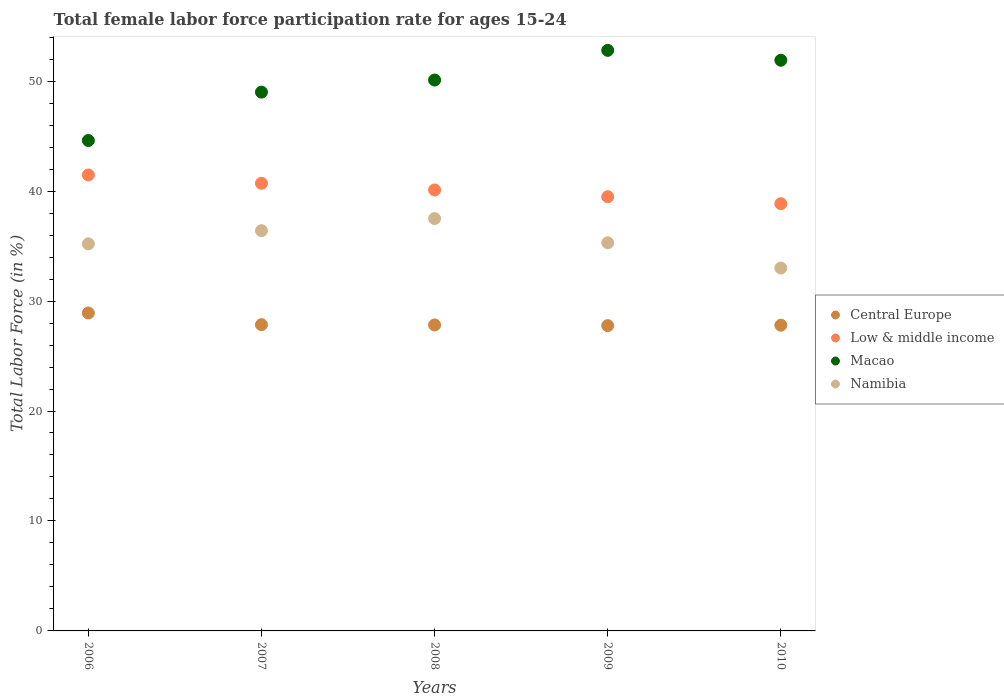How many different coloured dotlines are there?
Make the answer very short. 4. What is the female labor force participation rate in Macao in 2010?
Ensure brevity in your answer.  51.9. Across all years, what is the maximum female labor force participation rate in Central Europe?
Give a very brief answer. 28.91. Across all years, what is the minimum female labor force participation rate in Low & middle income?
Make the answer very short. 38.86. In which year was the female labor force participation rate in Namibia minimum?
Your answer should be very brief. 2010. What is the total female labor force participation rate in Central Europe in the graph?
Offer a very short reply. 140.16. What is the difference between the female labor force participation rate in Macao in 2007 and that in 2009?
Provide a short and direct response. -3.8. What is the difference between the female labor force participation rate in Central Europe in 2010 and the female labor force participation rate in Low & middle income in 2008?
Offer a terse response. -12.3. What is the average female labor force participation rate in Macao per year?
Offer a terse response. 49.68. In the year 2009, what is the difference between the female labor force participation rate in Low & middle income and female labor force participation rate in Namibia?
Provide a short and direct response. 4.19. In how many years, is the female labor force participation rate in Namibia greater than 52 %?
Offer a very short reply. 0. What is the ratio of the female labor force participation rate in Low & middle income in 2006 to that in 2010?
Provide a short and direct response. 1.07. Is the difference between the female labor force participation rate in Low & middle income in 2007 and 2009 greater than the difference between the female labor force participation rate in Namibia in 2007 and 2009?
Ensure brevity in your answer.  Yes. What is the difference between the highest and the second highest female labor force participation rate in Low & middle income?
Make the answer very short. 0.75. What is the difference between the highest and the lowest female labor force participation rate in Macao?
Provide a short and direct response. 8.2. In how many years, is the female labor force participation rate in Low & middle income greater than the average female labor force participation rate in Low & middle income taken over all years?
Keep it short and to the point. 2. Is the sum of the female labor force participation rate in Central Europe in 2007 and 2010 greater than the maximum female labor force participation rate in Namibia across all years?
Your response must be concise. Yes. Is the female labor force participation rate in Namibia strictly less than the female labor force participation rate in Low & middle income over the years?
Your answer should be very brief. Yes. What is the difference between two consecutive major ticks on the Y-axis?
Provide a short and direct response. 10. Are the values on the major ticks of Y-axis written in scientific E-notation?
Provide a succinct answer. No. Does the graph contain any zero values?
Offer a very short reply. No. How are the legend labels stacked?
Offer a very short reply. Vertical. What is the title of the graph?
Provide a short and direct response. Total female labor force participation rate for ages 15-24. Does "Kosovo" appear as one of the legend labels in the graph?
Offer a very short reply. No. What is the label or title of the X-axis?
Give a very brief answer. Years. What is the label or title of the Y-axis?
Make the answer very short. Total Labor Force (in %). What is the Total Labor Force (in %) of Central Europe in 2006?
Ensure brevity in your answer.  28.91. What is the Total Labor Force (in %) of Low & middle income in 2006?
Give a very brief answer. 41.47. What is the Total Labor Force (in %) in Macao in 2006?
Keep it short and to the point. 44.6. What is the Total Labor Force (in %) of Namibia in 2006?
Your answer should be very brief. 35.2. What is the Total Labor Force (in %) in Central Europe in 2007?
Provide a short and direct response. 27.85. What is the Total Labor Force (in %) in Low & middle income in 2007?
Ensure brevity in your answer.  40.71. What is the Total Labor Force (in %) of Macao in 2007?
Your answer should be very brief. 49. What is the Total Labor Force (in %) in Namibia in 2007?
Give a very brief answer. 36.4. What is the Total Labor Force (in %) of Central Europe in 2008?
Offer a terse response. 27.82. What is the Total Labor Force (in %) in Low & middle income in 2008?
Your answer should be very brief. 40.1. What is the Total Labor Force (in %) in Macao in 2008?
Make the answer very short. 50.1. What is the Total Labor Force (in %) of Namibia in 2008?
Provide a short and direct response. 37.5. What is the Total Labor Force (in %) in Central Europe in 2009?
Offer a terse response. 27.77. What is the Total Labor Force (in %) in Low & middle income in 2009?
Make the answer very short. 39.49. What is the Total Labor Force (in %) of Macao in 2009?
Ensure brevity in your answer.  52.8. What is the Total Labor Force (in %) of Namibia in 2009?
Provide a short and direct response. 35.3. What is the Total Labor Force (in %) of Central Europe in 2010?
Your response must be concise. 27.8. What is the Total Labor Force (in %) of Low & middle income in 2010?
Ensure brevity in your answer.  38.86. What is the Total Labor Force (in %) in Macao in 2010?
Offer a terse response. 51.9. What is the Total Labor Force (in %) in Namibia in 2010?
Ensure brevity in your answer.  33. Across all years, what is the maximum Total Labor Force (in %) of Central Europe?
Ensure brevity in your answer.  28.91. Across all years, what is the maximum Total Labor Force (in %) of Low & middle income?
Keep it short and to the point. 41.47. Across all years, what is the maximum Total Labor Force (in %) of Macao?
Provide a short and direct response. 52.8. Across all years, what is the maximum Total Labor Force (in %) in Namibia?
Provide a short and direct response. 37.5. Across all years, what is the minimum Total Labor Force (in %) of Central Europe?
Keep it short and to the point. 27.77. Across all years, what is the minimum Total Labor Force (in %) of Low & middle income?
Your response must be concise. 38.86. Across all years, what is the minimum Total Labor Force (in %) in Macao?
Give a very brief answer. 44.6. Across all years, what is the minimum Total Labor Force (in %) of Namibia?
Offer a terse response. 33. What is the total Total Labor Force (in %) of Central Europe in the graph?
Give a very brief answer. 140.16. What is the total Total Labor Force (in %) of Low & middle income in the graph?
Your response must be concise. 200.62. What is the total Total Labor Force (in %) in Macao in the graph?
Provide a short and direct response. 248.4. What is the total Total Labor Force (in %) in Namibia in the graph?
Keep it short and to the point. 177.4. What is the difference between the Total Labor Force (in %) of Central Europe in 2006 and that in 2007?
Give a very brief answer. 1.06. What is the difference between the Total Labor Force (in %) in Low & middle income in 2006 and that in 2007?
Provide a succinct answer. 0.75. What is the difference between the Total Labor Force (in %) of Macao in 2006 and that in 2007?
Your answer should be compact. -4.4. What is the difference between the Total Labor Force (in %) of Central Europe in 2006 and that in 2008?
Provide a short and direct response. 1.09. What is the difference between the Total Labor Force (in %) of Low & middle income in 2006 and that in 2008?
Provide a short and direct response. 1.37. What is the difference between the Total Labor Force (in %) in Central Europe in 2006 and that in 2009?
Keep it short and to the point. 1.15. What is the difference between the Total Labor Force (in %) in Low & middle income in 2006 and that in 2009?
Your answer should be compact. 1.98. What is the difference between the Total Labor Force (in %) in Macao in 2006 and that in 2009?
Make the answer very short. -8.2. What is the difference between the Total Labor Force (in %) of Central Europe in 2006 and that in 2010?
Your answer should be compact. 1.11. What is the difference between the Total Labor Force (in %) in Low & middle income in 2006 and that in 2010?
Offer a very short reply. 2.61. What is the difference between the Total Labor Force (in %) of Central Europe in 2007 and that in 2008?
Make the answer very short. 0.03. What is the difference between the Total Labor Force (in %) of Low & middle income in 2007 and that in 2008?
Ensure brevity in your answer.  0.61. What is the difference between the Total Labor Force (in %) in Central Europe in 2007 and that in 2009?
Offer a terse response. 0.08. What is the difference between the Total Labor Force (in %) of Low & middle income in 2007 and that in 2009?
Ensure brevity in your answer.  1.23. What is the difference between the Total Labor Force (in %) in Namibia in 2007 and that in 2009?
Make the answer very short. 1.1. What is the difference between the Total Labor Force (in %) in Central Europe in 2007 and that in 2010?
Ensure brevity in your answer.  0.05. What is the difference between the Total Labor Force (in %) in Low & middle income in 2007 and that in 2010?
Ensure brevity in your answer.  1.86. What is the difference between the Total Labor Force (in %) of Macao in 2007 and that in 2010?
Offer a terse response. -2.9. What is the difference between the Total Labor Force (in %) of Namibia in 2007 and that in 2010?
Your answer should be compact. 3.4. What is the difference between the Total Labor Force (in %) of Central Europe in 2008 and that in 2009?
Provide a short and direct response. 0.06. What is the difference between the Total Labor Force (in %) in Low & middle income in 2008 and that in 2009?
Provide a succinct answer. 0.61. What is the difference between the Total Labor Force (in %) in Macao in 2008 and that in 2009?
Ensure brevity in your answer.  -2.7. What is the difference between the Total Labor Force (in %) of Namibia in 2008 and that in 2009?
Offer a very short reply. 2.2. What is the difference between the Total Labor Force (in %) in Central Europe in 2008 and that in 2010?
Keep it short and to the point. 0.02. What is the difference between the Total Labor Force (in %) in Low & middle income in 2008 and that in 2010?
Offer a very short reply. 1.24. What is the difference between the Total Labor Force (in %) in Macao in 2008 and that in 2010?
Your answer should be compact. -1.8. What is the difference between the Total Labor Force (in %) in Central Europe in 2009 and that in 2010?
Make the answer very short. -0.04. What is the difference between the Total Labor Force (in %) of Low & middle income in 2009 and that in 2010?
Make the answer very short. 0.63. What is the difference between the Total Labor Force (in %) in Central Europe in 2006 and the Total Labor Force (in %) in Low & middle income in 2007?
Provide a succinct answer. -11.8. What is the difference between the Total Labor Force (in %) of Central Europe in 2006 and the Total Labor Force (in %) of Macao in 2007?
Give a very brief answer. -20.09. What is the difference between the Total Labor Force (in %) of Central Europe in 2006 and the Total Labor Force (in %) of Namibia in 2007?
Give a very brief answer. -7.49. What is the difference between the Total Labor Force (in %) in Low & middle income in 2006 and the Total Labor Force (in %) in Macao in 2007?
Make the answer very short. -7.53. What is the difference between the Total Labor Force (in %) in Low & middle income in 2006 and the Total Labor Force (in %) in Namibia in 2007?
Your response must be concise. 5.07. What is the difference between the Total Labor Force (in %) of Central Europe in 2006 and the Total Labor Force (in %) of Low & middle income in 2008?
Offer a very short reply. -11.19. What is the difference between the Total Labor Force (in %) of Central Europe in 2006 and the Total Labor Force (in %) of Macao in 2008?
Your answer should be compact. -21.19. What is the difference between the Total Labor Force (in %) in Central Europe in 2006 and the Total Labor Force (in %) in Namibia in 2008?
Provide a succinct answer. -8.59. What is the difference between the Total Labor Force (in %) of Low & middle income in 2006 and the Total Labor Force (in %) of Macao in 2008?
Give a very brief answer. -8.63. What is the difference between the Total Labor Force (in %) of Low & middle income in 2006 and the Total Labor Force (in %) of Namibia in 2008?
Provide a succinct answer. 3.97. What is the difference between the Total Labor Force (in %) in Central Europe in 2006 and the Total Labor Force (in %) in Low & middle income in 2009?
Offer a very short reply. -10.58. What is the difference between the Total Labor Force (in %) of Central Europe in 2006 and the Total Labor Force (in %) of Macao in 2009?
Your answer should be very brief. -23.89. What is the difference between the Total Labor Force (in %) of Central Europe in 2006 and the Total Labor Force (in %) of Namibia in 2009?
Your answer should be very brief. -6.39. What is the difference between the Total Labor Force (in %) of Low & middle income in 2006 and the Total Labor Force (in %) of Macao in 2009?
Provide a short and direct response. -11.33. What is the difference between the Total Labor Force (in %) of Low & middle income in 2006 and the Total Labor Force (in %) of Namibia in 2009?
Give a very brief answer. 6.17. What is the difference between the Total Labor Force (in %) of Macao in 2006 and the Total Labor Force (in %) of Namibia in 2009?
Your answer should be very brief. 9.3. What is the difference between the Total Labor Force (in %) in Central Europe in 2006 and the Total Labor Force (in %) in Low & middle income in 2010?
Offer a terse response. -9.95. What is the difference between the Total Labor Force (in %) in Central Europe in 2006 and the Total Labor Force (in %) in Macao in 2010?
Offer a terse response. -22.99. What is the difference between the Total Labor Force (in %) in Central Europe in 2006 and the Total Labor Force (in %) in Namibia in 2010?
Ensure brevity in your answer.  -4.09. What is the difference between the Total Labor Force (in %) in Low & middle income in 2006 and the Total Labor Force (in %) in Macao in 2010?
Provide a short and direct response. -10.43. What is the difference between the Total Labor Force (in %) of Low & middle income in 2006 and the Total Labor Force (in %) of Namibia in 2010?
Offer a terse response. 8.47. What is the difference between the Total Labor Force (in %) of Macao in 2006 and the Total Labor Force (in %) of Namibia in 2010?
Provide a short and direct response. 11.6. What is the difference between the Total Labor Force (in %) in Central Europe in 2007 and the Total Labor Force (in %) in Low & middle income in 2008?
Your answer should be compact. -12.25. What is the difference between the Total Labor Force (in %) of Central Europe in 2007 and the Total Labor Force (in %) of Macao in 2008?
Ensure brevity in your answer.  -22.25. What is the difference between the Total Labor Force (in %) in Central Europe in 2007 and the Total Labor Force (in %) in Namibia in 2008?
Your response must be concise. -9.65. What is the difference between the Total Labor Force (in %) in Low & middle income in 2007 and the Total Labor Force (in %) in Macao in 2008?
Provide a short and direct response. -9.39. What is the difference between the Total Labor Force (in %) in Low & middle income in 2007 and the Total Labor Force (in %) in Namibia in 2008?
Offer a very short reply. 3.21. What is the difference between the Total Labor Force (in %) in Macao in 2007 and the Total Labor Force (in %) in Namibia in 2008?
Your answer should be compact. 11.5. What is the difference between the Total Labor Force (in %) of Central Europe in 2007 and the Total Labor Force (in %) of Low & middle income in 2009?
Your answer should be compact. -11.64. What is the difference between the Total Labor Force (in %) of Central Europe in 2007 and the Total Labor Force (in %) of Macao in 2009?
Provide a succinct answer. -24.95. What is the difference between the Total Labor Force (in %) of Central Europe in 2007 and the Total Labor Force (in %) of Namibia in 2009?
Your answer should be very brief. -7.45. What is the difference between the Total Labor Force (in %) of Low & middle income in 2007 and the Total Labor Force (in %) of Macao in 2009?
Your answer should be compact. -12.09. What is the difference between the Total Labor Force (in %) of Low & middle income in 2007 and the Total Labor Force (in %) of Namibia in 2009?
Ensure brevity in your answer.  5.41. What is the difference between the Total Labor Force (in %) in Central Europe in 2007 and the Total Labor Force (in %) in Low & middle income in 2010?
Offer a terse response. -11.01. What is the difference between the Total Labor Force (in %) of Central Europe in 2007 and the Total Labor Force (in %) of Macao in 2010?
Keep it short and to the point. -24.05. What is the difference between the Total Labor Force (in %) of Central Europe in 2007 and the Total Labor Force (in %) of Namibia in 2010?
Your answer should be very brief. -5.15. What is the difference between the Total Labor Force (in %) of Low & middle income in 2007 and the Total Labor Force (in %) of Macao in 2010?
Give a very brief answer. -11.19. What is the difference between the Total Labor Force (in %) of Low & middle income in 2007 and the Total Labor Force (in %) of Namibia in 2010?
Keep it short and to the point. 7.71. What is the difference between the Total Labor Force (in %) in Central Europe in 2008 and the Total Labor Force (in %) in Low & middle income in 2009?
Offer a terse response. -11.66. What is the difference between the Total Labor Force (in %) of Central Europe in 2008 and the Total Labor Force (in %) of Macao in 2009?
Make the answer very short. -24.98. What is the difference between the Total Labor Force (in %) in Central Europe in 2008 and the Total Labor Force (in %) in Namibia in 2009?
Provide a succinct answer. -7.48. What is the difference between the Total Labor Force (in %) of Low & middle income in 2008 and the Total Labor Force (in %) of Macao in 2009?
Keep it short and to the point. -12.7. What is the difference between the Total Labor Force (in %) in Low & middle income in 2008 and the Total Labor Force (in %) in Namibia in 2009?
Keep it short and to the point. 4.8. What is the difference between the Total Labor Force (in %) in Central Europe in 2008 and the Total Labor Force (in %) in Low & middle income in 2010?
Your answer should be compact. -11.03. What is the difference between the Total Labor Force (in %) of Central Europe in 2008 and the Total Labor Force (in %) of Macao in 2010?
Provide a succinct answer. -24.08. What is the difference between the Total Labor Force (in %) in Central Europe in 2008 and the Total Labor Force (in %) in Namibia in 2010?
Your answer should be compact. -5.18. What is the difference between the Total Labor Force (in %) in Low & middle income in 2008 and the Total Labor Force (in %) in Macao in 2010?
Keep it short and to the point. -11.8. What is the difference between the Total Labor Force (in %) in Low & middle income in 2008 and the Total Labor Force (in %) in Namibia in 2010?
Keep it short and to the point. 7.1. What is the difference between the Total Labor Force (in %) in Macao in 2008 and the Total Labor Force (in %) in Namibia in 2010?
Make the answer very short. 17.1. What is the difference between the Total Labor Force (in %) in Central Europe in 2009 and the Total Labor Force (in %) in Low & middle income in 2010?
Your answer should be compact. -11.09. What is the difference between the Total Labor Force (in %) in Central Europe in 2009 and the Total Labor Force (in %) in Macao in 2010?
Ensure brevity in your answer.  -24.13. What is the difference between the Total Labor Force (in %) in Central Europe in 2009 and the Total Labor Force (in %) in Namibia in 2010?
Your response must be concise. -5.23. What is the difference between the Total Labor Force (in %) of Low & middle income in 2009 and the Total Labor Force (in %) of Macao in 2010?
Provide a succinct answer. -12.41. What is the difference between the Total Labor Force (in %) of Low & middle income in 2009 and the Total Labor Force (in %) of Namibia in 2010?
Your response must be concise. 6.49. What is the difference between the Total Labor Force (in %) of Macao in 2009 and the Total Labor Force (in %) of Namibia in 2010?
Keep it short and to the point. 19.8. What is the average Total Labor Force (in %) of Central Europe per year?
Your answer should be compact. 28.03. What is the average Total Labor Force (in %) of Low & middle income per year?
Keep it short and to the point. 40.12. What is the average Total Labor Force (in %) of Macao per year?
Keep it short and to the point. 49.68. What is the average Total Labor Force (in %) in Namibia per year?
Offer a very short reply. 35.48. In the year 2006, what is the difference between the Total Labor Force (in %) in Central Europe and Total Labor Force (in %) in Low & middle income?
Give a very brief answer. -12.55. In the year 2006, what is the difference between the Total Labor Force (in %) in Central Europe and Total Labor Force (in %) in Macao?
Provide a short and direct response. -15.69. In the year 2006, what is the difference between the Total Labor Force (in %) of Central Europe and Total Labor Force (in %) of Namibia?
Provide a succinct answer. -6.29. In the year 2006, what is the difference between the Total Labor Force (in %) of Low & middle income and Total Labor Force (in %) of Macao?
Provide a short and direct response. -3.13. In the year 2006, what is the difference between the Total Labor Force (in %) in Low & middle income and Total Labor Force (in %) in Namibia?
Your answer should be very brief. 6.27. In the year 2006, what is the difference between the Total Labor Force (in %) in Macao and Total Labor Force (in %) in Namibia?
Provide a short and direct response. 9.4. In the year 2007, what is the difference between the Total Labor Force (in %) of Central Europe and Total Labor Force (in %) of Low & middle income?
Your answer should be very brief. -12.86. In the year 2007, what is the difference between the Total Labor Force (in %) of Central Europe and Total Labor Force (in %) of Macao?
Provide a short and direct response. -21.15. In the year 2007, what is the difference between the Total Labor Force (in %) of Central Europe and Total Labor Force (in %) of Namibia?
Provide a short and direct response. -8.55. In the year 2007, what is the difference between the Total Labor Force (in %) in Low & middle income and Total Labor Force (in %) in Macao?
Provide a short and direct response. -8.29. In the year 2007, what is the difference between the Total Labor Force (in %) of Low & middle income and Total Labor Force (in %) of Namibia?
Offer a very short reply. 4.31. In the year 2008, what is the difference between the Total Labor Force (in %) of Central Europe and Total Labor Force (in %) of Low & middle income?
Offer a very short reply. -12.28. In the year 2008, what is the difference between the Total Labor Force (in %) in Central Europe and Total Labor Force (in %) in Macao?
Your answer should be very brief. -22.28. In the year 2008, what is the difference between the Total Labor Force (in %) of Central Europe and Total Labor Force (in %) of Namibia?
Your answer should be very brief. -9.68. In the year 2008, what is the difference between the Total Labor Force (in %) in Low & middle income and Total Labor Force (in %) in Macao?
Provide a succinct answer. -10. In the year 2008, what is the difference between the Total Labor Force (in %) of Low & middle income and Total Labor Force (in %) of Namibia?
Offer a terse response. 2.6. In the year 2009, what is the difference between the Total Labor Force (in %) of Central Europe and Total Labor Force (in %) of Low & middle income?
Keep it short and to the point. -11.72. In the year 2009, what is the difference between the Total Labor Force (in %) in Central Europe and Total Labor Force (in %) in Macao?
Ensure brevity in your answer.  -25.03. In the year 2009, what is the difference between the Total Labor Force (in %) of Central Europe and Total Labor Force (in %) of Namibia?
Keep it short and to the point. -7.53. In the year 2009, what is the difference between the Total Labor Force (in %) in Low & middle income and Total Labor Force (in %) in Macao?
Provide a succinct answer. -13.31. In the year 2009, what is the difference between the Total Labor Force (in %) of Low & middle income and Total Labor Force (in %) of Namibia?
Give a very brief answer. 4.19. In the year 2010, what is the difference between the Total Labor Force (in %) of Central Europe and Total Labor Force (in %) of Low & middle income?
Your answer should be very brief. -11.05. In the year 2010, what is the difference between the Total Labor Force (in %) of Central Europe and Total Labor Force (in %) of Macao?
Give a very brief answer. -24.1. In the year 2010, what is the difference between the Total Labor Force (in %) in Central Europe and Total Labor Force (in %) in Namibia?
Offer a terse response. -5.2. In the year 2010, what is the difference between the Total Labor Force (in %) of Low & middle income and Total Labor Force (in %) of Macao?
Make the answer very short. -13.04. In the year 2010, what is the difference between the Total Labor Force (in %) in Low & middle income and Total Labor Force (in %) in Namibia?
Provide a succinct answer. 5.86. What is the ratio of the Total Labor Force (in %) in Central Europe in 2006 to that in 2007?
Your answer should be very brief. 1.04. What is the ratio of the Total Labor Force (in %) in Low & middle income in 2006 to that in 2007?
Offer a terse response. 1.02. What is the ratio of the Total Labor Force (in %) of Macao in 2006 to that in 2007?
Offer a very short reply. 0.91. What is the ratio of the Total Labor Force (in %) of Central Europe in 2006 to that in 2008?
Offer a terse response. 1.04. What is the ratio of the Total Labor Force (in %) in Low & middle income in 2006 to that in 2008?
Keep it short and to the point. 1.03. What is the ratio of the Total Labor Force (in %) of Macao in 2006 to that in 2008?
Provide a short and direct response. 0.89. What is the ratio of the Total Labor Force (in %) in Namibia in 2006 to that in 2008?
Your answer should be very brief. 0.94. What is the ratio of the Total Labor Force (in %) in Central Europe in 2006 to that in 2009?
Offer a terse response. 1.04. What is the ratio of the Total Labor Force (in %) of Low & middle income in 2006 to that in 2009?
Your answer should be very brief. 1.05. What is the ratio of the Total Labor Force (in %) in Macao in 2006 to that in 2009?
Give a very brief answer. 0.84. What is the ratio of the Total Labor Force (in %) in Central Europe in 2006 to that in 2010?
Offer a very short reply. 1.04. What is the ratio of the Total Labor Force (in %) of Low & middle income in 2006 to that in 2010?
Your answer should be compact. 1.07. What is the ratio of the Total Labor Force (in %) in Macao in 2006 to that in 2010?
Provide a short and direct response. 0.86. What is the ratio of the Total Labor Force (in %) in Namibia in 2006 to that in 2010?
Provide a short and direct response. 1.07. What is the ratio of the Total Labor Force (in %) in Low & middle income in 2007 to that in 2008?
Provide a short and direct response. 1.02. What is the ratio of the Total Labor Force (in %) of Macao in 2007 to that in 2008?
Your answer should be compact. 0.98. What is the ratio of the Total Labor Force (in %) in Namibia in 2007 to that in 2008?
Make the answer very short. 0.97. What is the ratio of the Total Labor Force (in %) in Central Europe in 2007 to that in 2009?
Provide a short and direct response. 1. What is the ratio of the Total Labor Force (in %) in Low & middle income in 2007 to that in 2009?
Give a very brief answer. 1.03. What is the ratio of the Total Labor Force (in %) in Macao in 2007 to that in 2009?
Ensure brevity in your answer.  0.93. What is the ratio of the Total Labor Force (in %) of Namibia in 2007 to that in 2009?
Provide a short and direct response. 1.03. What is the ratio of the Total Labor Force (in %) of Low & middle income in 2007 to that in 2010?
Give a very brief answer. 1.05. What is the ratio of the Total Labor Force (in %) in Macao in 2007 to that in 2010?
Offer a very short reply. 0.94. What is the ratio of the Total Labor Force (in %) of Namibia in 2007 to that in 2010?
Keep it short and to the point. 1.1. What is the ratio of the Total Labor Force (in %) of Low & middle income in 2008 to that in 2009?
Offer a very short reply. 1.02. What is the ratio of the Total Labor Force (in %) of Macao in 2008 to that in 2009?
Offer a very short reply. 0.95. What is the ratio of the Total Labor Force (in %) of Namibia in 2008 to that in 2009?
Offer a terse response. 1.06. What is the ratio of the Total Labor Force (in %) in Low & middle income in 2008 to that in 2010?
Your response must be concise. 1.03. What is the ratio of the Total Labor Force (in %) in Macao in 2008 to that in 2010?
Make the answer very short. 0.97. What is the ratio of the Total Labor Force (in %) of Namibia in 2008 to that in 2010?
Ensure brevity in your answer.  1.14. What is the ratio of the Total Labor Force (in %) of Low & middle income in 2009 to that in 2010?
Your answer should be compact. 1.02. What is the ratio of the Total Labor Force (in %) of Macao in 2009 to that in 2010?
Keep it short and to the point. 1.02. What is the ratio of the Total Labor Force (in %) of Namibia in 2009 to that in 2010?
Your response must be concise. 1.07. What is the difference between the highest and the second highest Total Labor Force (in %) of Central Europe?
Provide a succinct answer. 1.06. What is the difference between the highest and the second highest Total Labor Force (in %) in Low & middle income?
Your answer should be compact. 0.75. What is the difference between the highest and the lowest Total Labor Force (in %) in Central Europe?
Provide a succinct answer. 1.15. What is the difference between the highest and the lowest Total Labor Force (in %) in Low & middle income?
Your answer should be compact. 2.61. What is the difference between the highest and the lowest Total Labor Force (in %) in Namibia?
Make the answer very short. 4.5. 